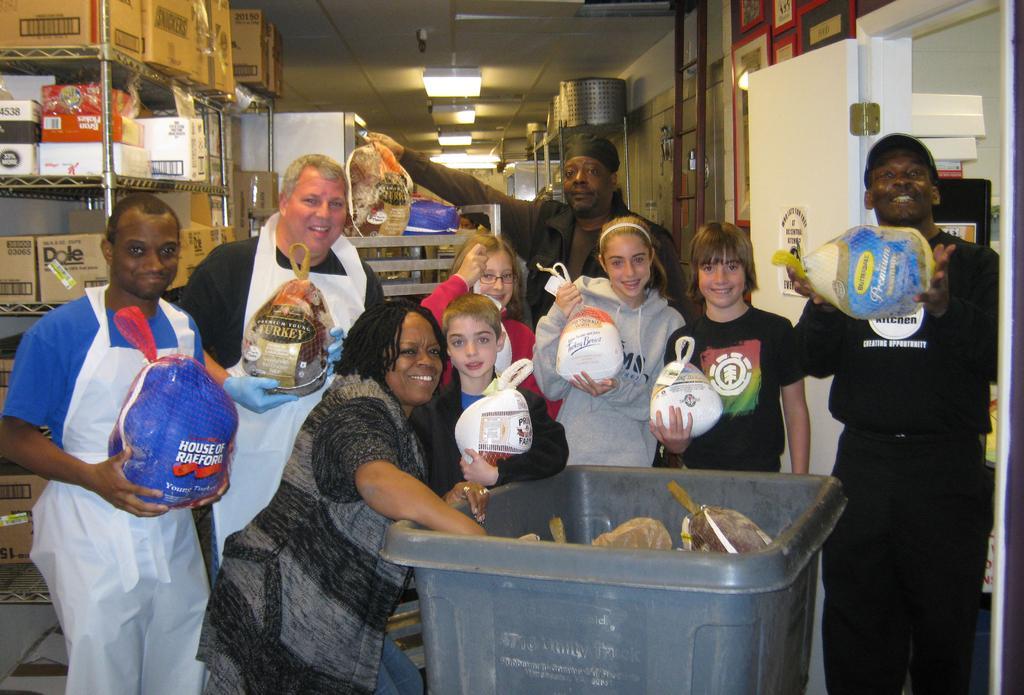In one or two sentences, can you explain what this image depicts? Here people are standing holding objects, here there are boxes in the shelf, there is roof with the lights, this is door. 